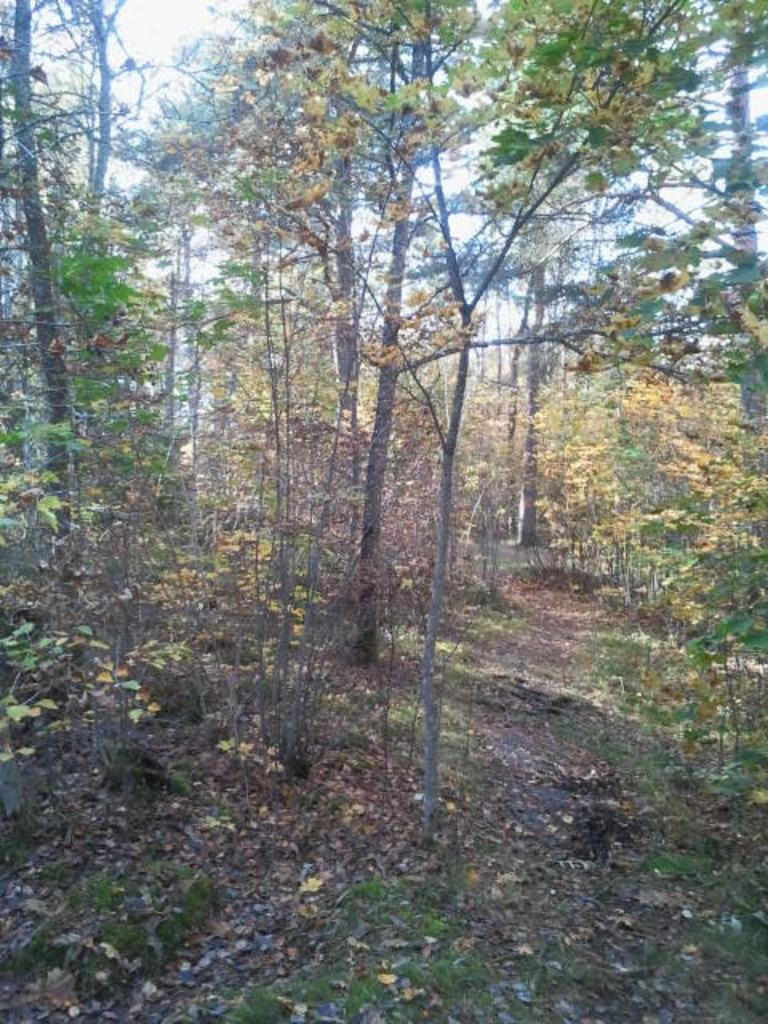What type of vegetation can be seen in the image? There are trees in the image. What part of the natural environment is visible in the image? The sky is visible in the image. What type of apple is being ordered on the ship in the image? There is no apple or ship present in the image; it only features trees and the sky. 